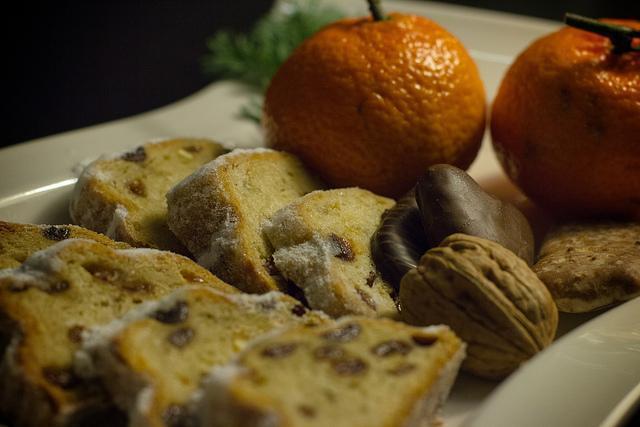What is the name of the nut on the plate?
Choose the correct response, then elucidate: 'Answer: answer
Rationale: rationale.'
Options: Peanut, walnut, cashew, pistachio. Answer: walnut.
Rationale: Walnuts are shown on the plate. 